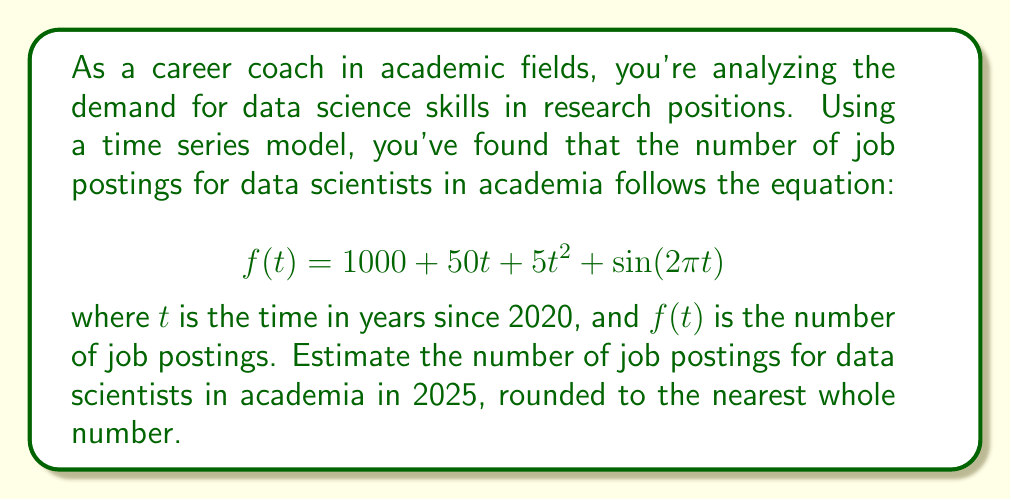Could you help me with this problem? To solve this problem, we need to follow these steps:

1. Identify the year we're forecasting for:
   2025 is 5 years after 2020, so $t = 5$

2. Substitute $t = 5$ into the given equation:
   $$f(5) = 1000 + 50(5) + 5(5)^2 + \sin(2\pi(5))$$

3. Simplify the expression:
   $$f(5) = 1000 + 250 + 5(25) + \sin(10\pi)$$
   $$f(5) = 1000 + 250 + 125 + \sin(10\pi)$$
   $$f(5) = 1375 + \sin(10\pi)$$

4. Calculate $\sin(10\pi)$:
   $\sin(10\pi) = 0$ (since sine is 0 at multiples of $\pi$)

5. Finalize the calculation:
   $$f(5) = 1375 + 0 = 1375$$

6. Round to the nearest whole number:
   1375 is already a whole number, so no rounding is necessary.

Therefore, the estimated number of job postings for data scientists in academia in 2025 is 1375.
Answer: 1375 